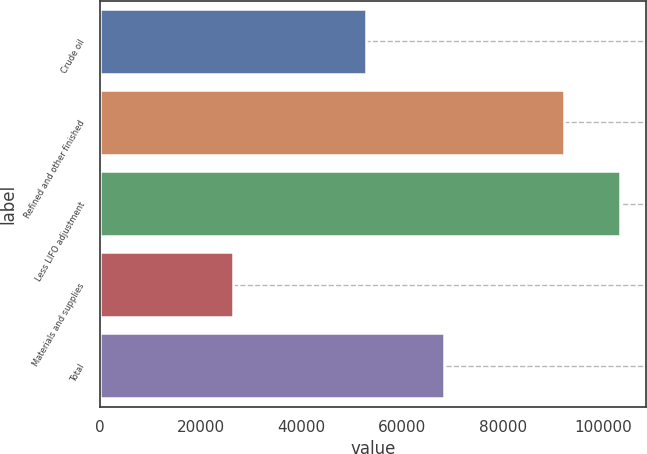Convert chart. <chart><loc_0><loc_0><loc_500><loc_500><bar_chart><fcel>Crude oil<fcel>Refined and other finished<fcel>Less LIFO adjustment<fcel>Materials and supplies<fcel>Total<nl><fcel>52878<fcel>92154<fcel>103318<fcel>26516<fcel>68230<nl></chart> 